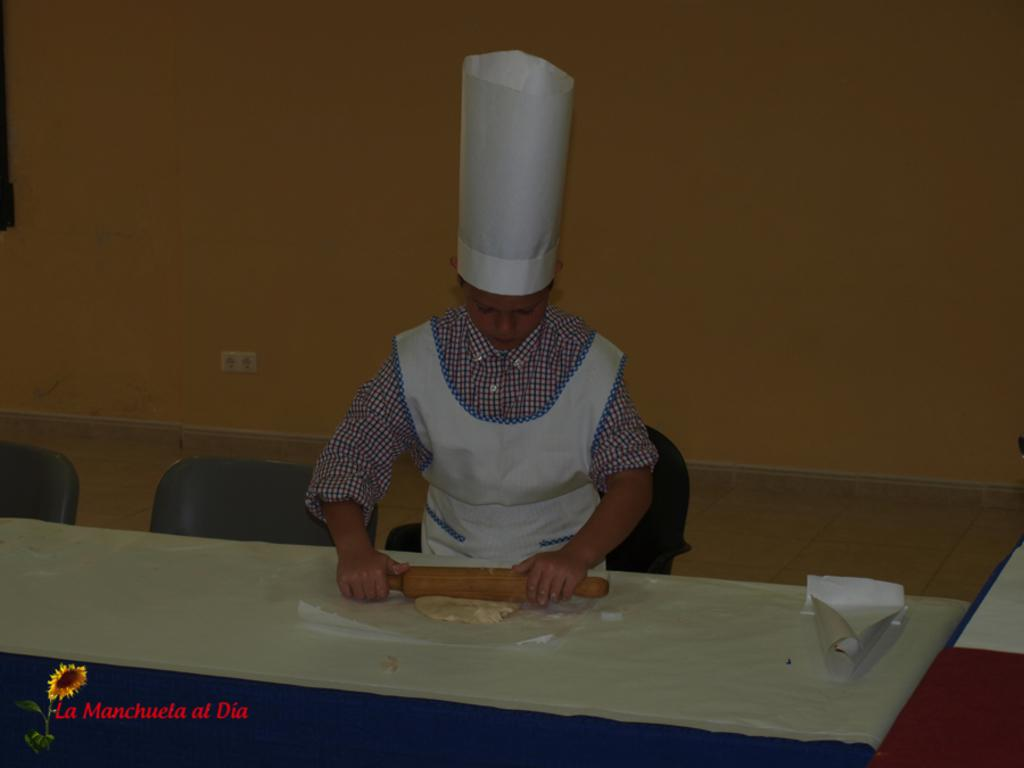What is the main subject in the image? There is a person in the image. What is the person interacting with in the image? The person is likely interacting with a table, as there is a table in the image. Are there any other furniture items visible in the image? Yes, there are chairs in the image. What can be seen in the background of the image? There is a wall in the background of the image. How does the person add numbers in the image? There is no indication in the image that the person is adding numbers or performing any mathematical operations. 